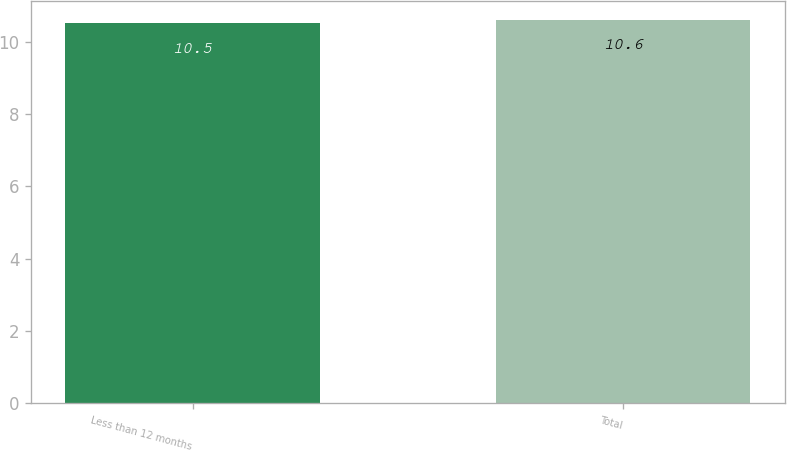Convert chart. <chart><loc_0><loc_0><loc_500><loc_500><bar_chart><fcel>Less than 12 months<fcel>Total<nl><fcel>10.5<fcel>10.6<nl></chart> 